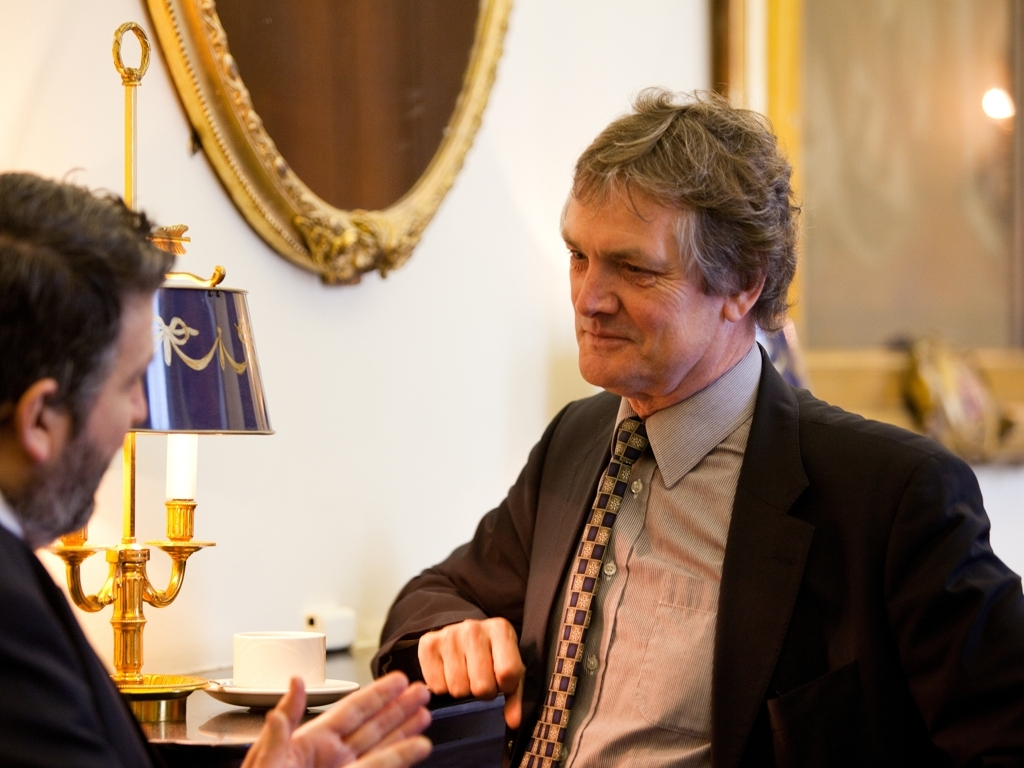What might be the possible topics of discussion between the two men? Given the formal attire and serious expressions, they could be discussing a range of professional matters such as business strategies, legal affairs, political issues, negotiations, or other matters that require discretion and thoughtful consideration. The setting doesn’t seem casual, which suggests that the topics are likely to be significant and perhaps impactful in a professional context. 